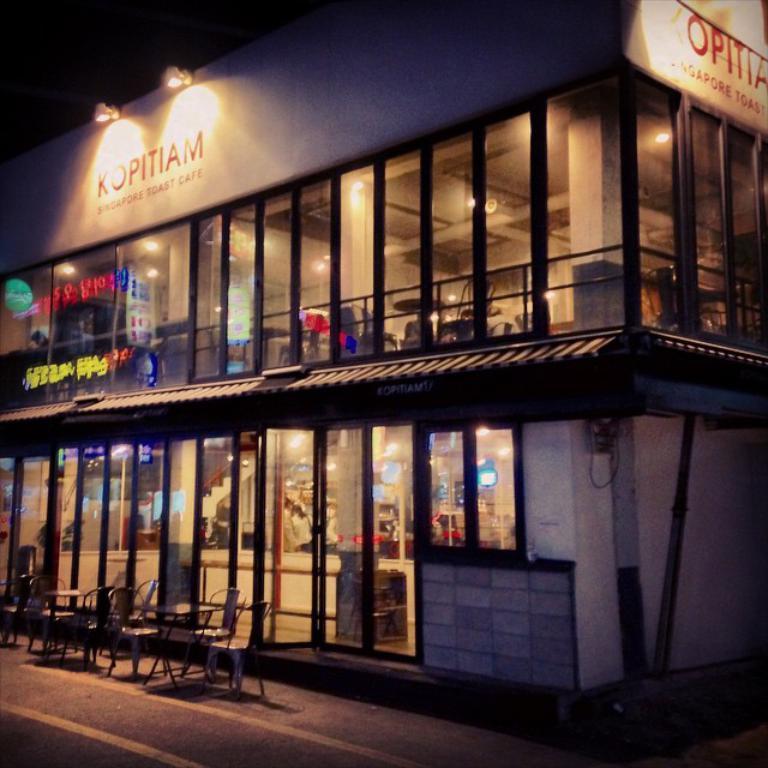How would you summarize this image in a sentence or two? In this image, we can see a building with walls and windows. Here there is a railing, chairs, tables, lights, banner and pole. At the bottom, there is a road. 